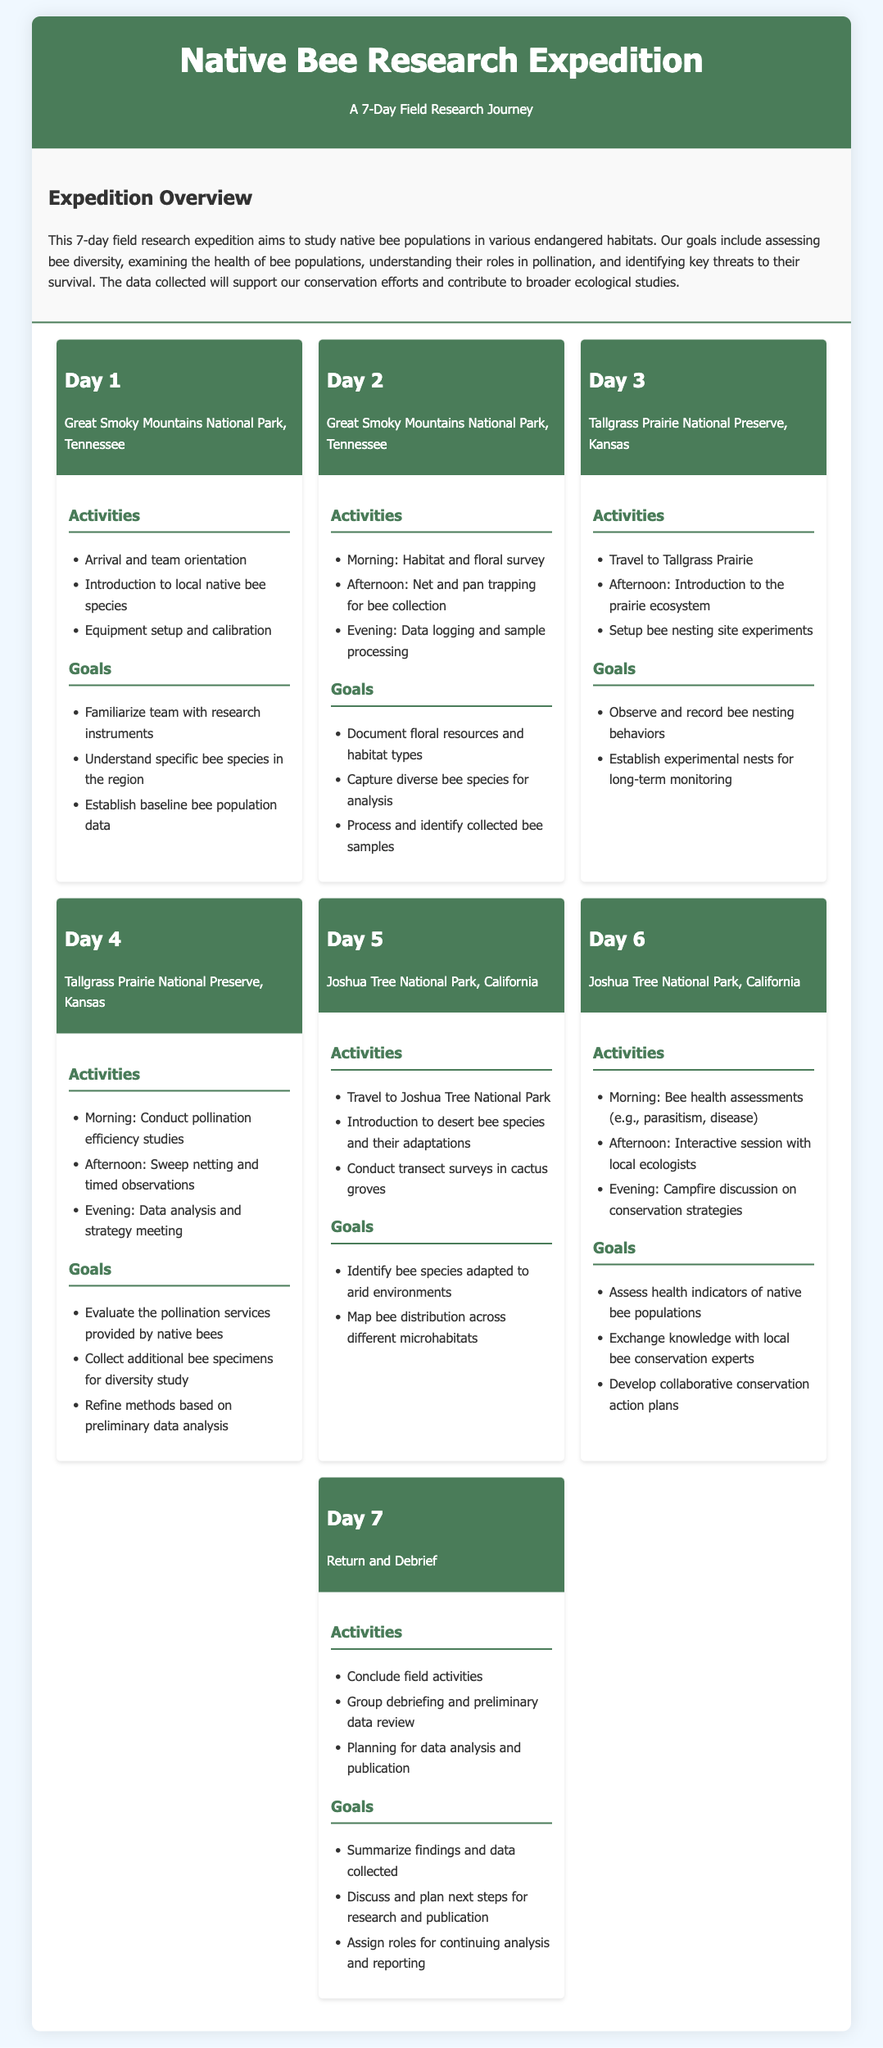What is the duration of the expedition? The document states it as a 7-day expedition.
Answer: 7 days What is the first location visited during the expedition? The document lists Great Smoky Mountains National Park as the first location.
Answer: Great Smoky Mountains National Park Which activities are planned for Day 4? Day 4 includes conducting pollination efficiency studies, sweep netting, and data analysis.
Answer: Conduct pollination efficiency studies, sweep netting, data analysis What is one goal listed for Day 5? The goal for Day 5 includes identifying bee species adapted to arid environments.
Answer: Identify bee species adapted to arid environments On which day do participants conduct bee health assessments? According to the document, bee health assessments occur on Day 6.
Answer: Day 6 What type of survey is conducted on Day 2? The document indicates that a habitat and floral survey is conducted on Day 2.
Answer: Habitat and floral survey How many locations are visited during the expedition? The document mentions Great Smoky Mountains, Tallgrass Prairie, and Joshua Tree, totaling three locations.
Answer: Three locations What is a goal for the final day of the expedition? The document states that one goal is to summarize findings and data collected.
Answer: Summarize findings and data collected 